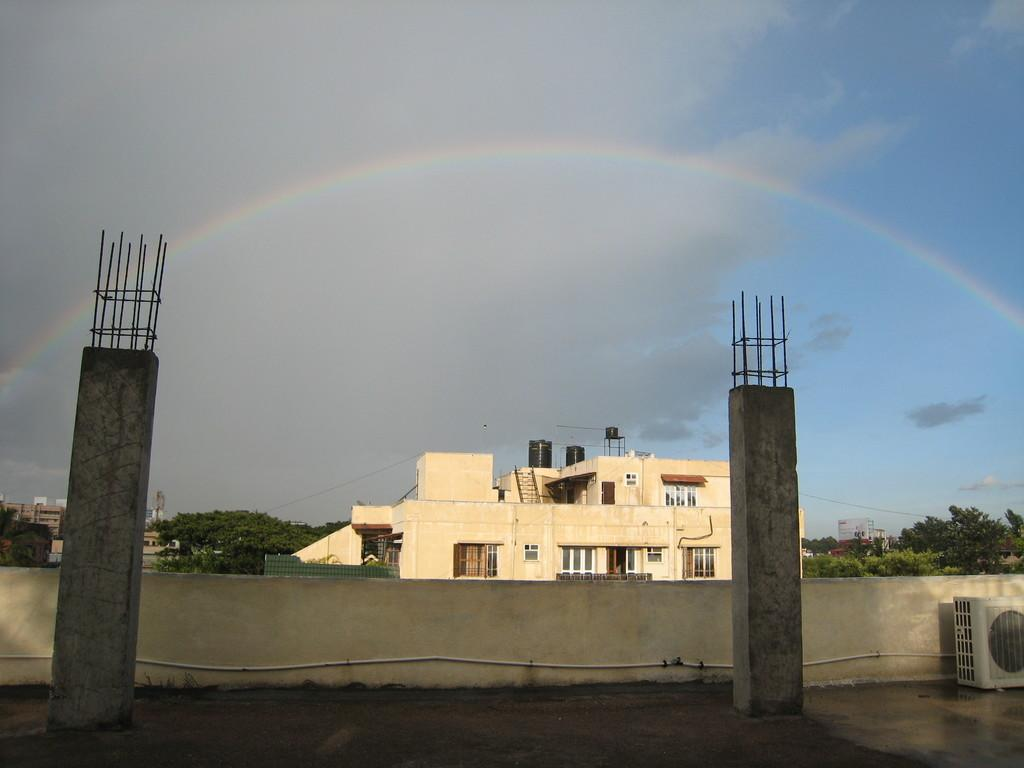What is located in the foreground of the image? There is a slab and two pillars in the foreground of the image. What can be seen on the right side of the image? There is an AC on the right side of the image. What is visible in the background of the image? Buildings, trees, cables, a rainbow, and the sky are visible in the background of the image. Can you tell me how many toes are visible on the rainbow in the image? There are no toes visible on the rainbow in the image, as a rainbow is a natural phenomenon and not a part of the human body. What type of lipstick is the rainbow wearing in the image? There is no lipstick or any indication of makeup on the rainbow in the image, as a rainbow is a natural phenomenon and not a sentient being. 